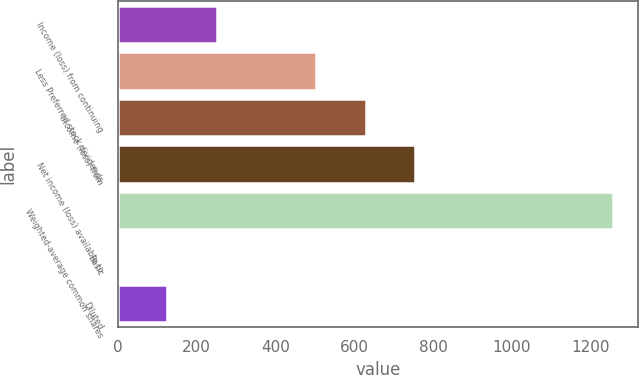<chart> <loc_0><loc_0><loc_500><loc_500><bar_chart><fcel>Income (loss) from continuing<fcel>Less Preferred stock dividends<fcel>Income (loss) from<fcel>Net income (loss) available to<fcel>Weighted-average common shares<fcel>Basic<fcel>Diluted<nl><fcel>251.62<fcel>503.22<fcel>629.02<fcel>754.82<fcel>1258<fcel>0.02<fcel>125.82<nl></chart> 